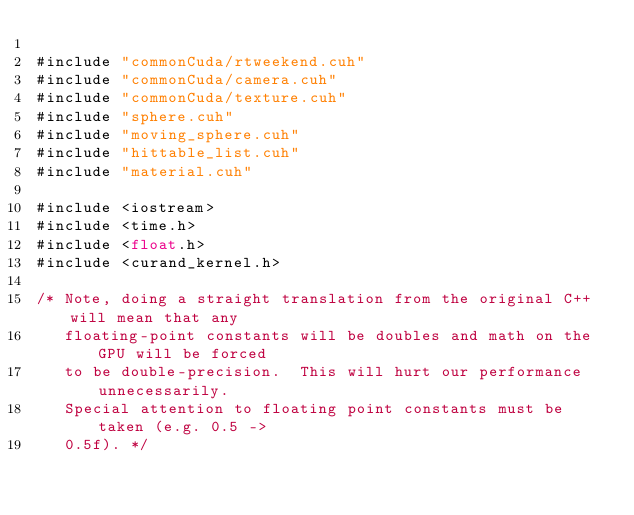Convert code to text. <code><loc_0><loc_0><loc_500><loc_500><_Cuda_>
#include "commonCuda/rtweekend.cuh"
#include "commonCuda/camera.cuh"
#include "commonCuda/texture.cuh"
#include "sphere.cuh"
#include "moving_sphere.cuh"
#include "hittable_list.cuh"
#include "material.cuh"

#include <iostream>
#include <time.h>
#include <float.h>
#include <curand_kernel.h>

/* Note, doing a straight translation from the original C++ will mean that any
   floating-point constants will be doubles and math on the GPU will be forced
   to be double-precision.  This will hurt our performance unnecessarily.
   Special attention to floating point constants must be taken (e.g. 0.5 ->
   0.5f). */
</code> 